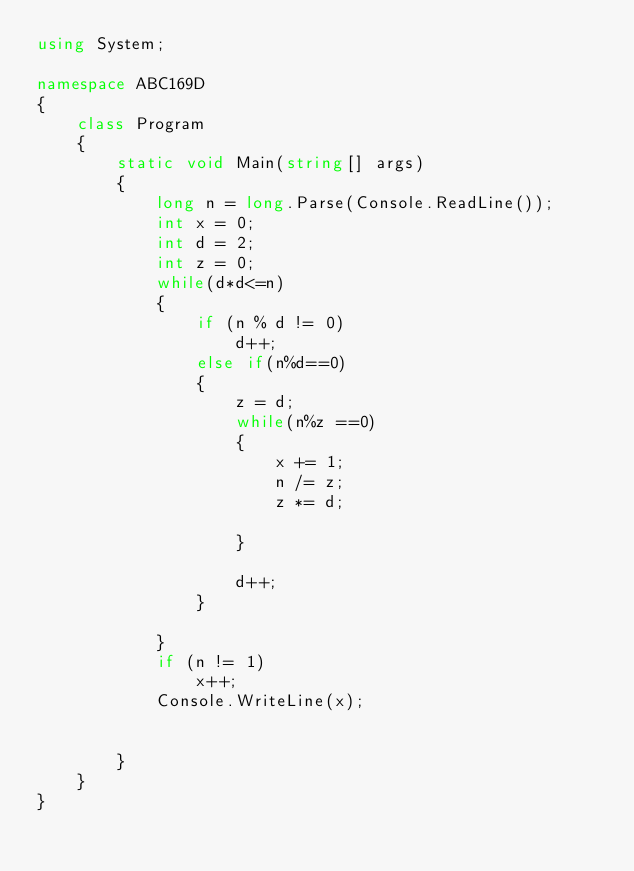<code> <loc_0><loc_0><loc_500><loc_500><_C#_>using System;

namespace ABC169D
{
    class Program
    {
        static void Main(string[] args)
        {
            long n = long.Parse(Console.ReadLine());
            int x = 0;
            int d = 2;
            int z = 0;
            while(d*d<=n)
            {
                if (n % d != 0)
                    d++;
                else if(n%d==0)
                {
                    z = d;
                    while(n%z ==0)
                    {
                        x += 1;
                        n /= z;
                        z *= d;

                    }
                    
                    d++;
                }

            }
            if (n != 1)
                x++;
            Console.WriteLine(x);


        }
    }
}
</code> 